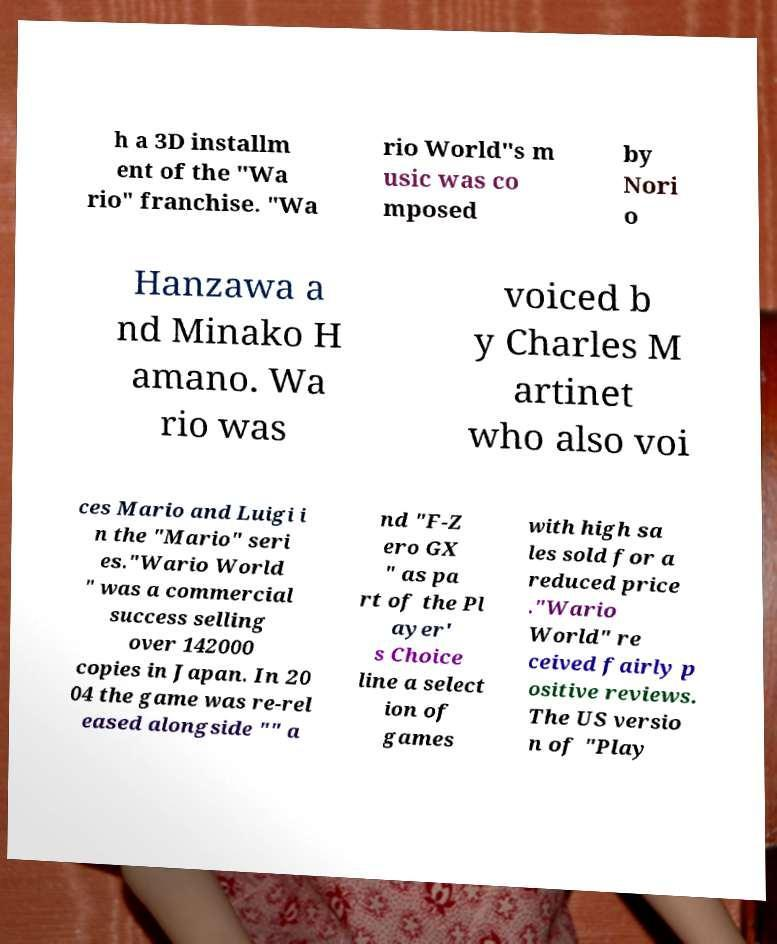Could you assist in decoding the text presented in this image and type it out clearly? h a 3D installm ent of the "Wa rio" franchise. "Wa rio World"s m usic was co mposed by Nori o Hanzawa a nd Minako H amano. Wa rio was voiced b y Charles M artinet who also voi ces Mario and Luigi i n the "Mario" seri es."Wario World " was a commercial success selling over 142000 copies in Japan. In 20 04 the game was re-rel eased alongside "" a nd "F-Z ero GX " as pa rt of the Pl ayer' s Choice line a select ion of games with high sa les sold for a reduced price ."Wario World" re ceived fairly p ositive reviews. The US versio n of "Play 